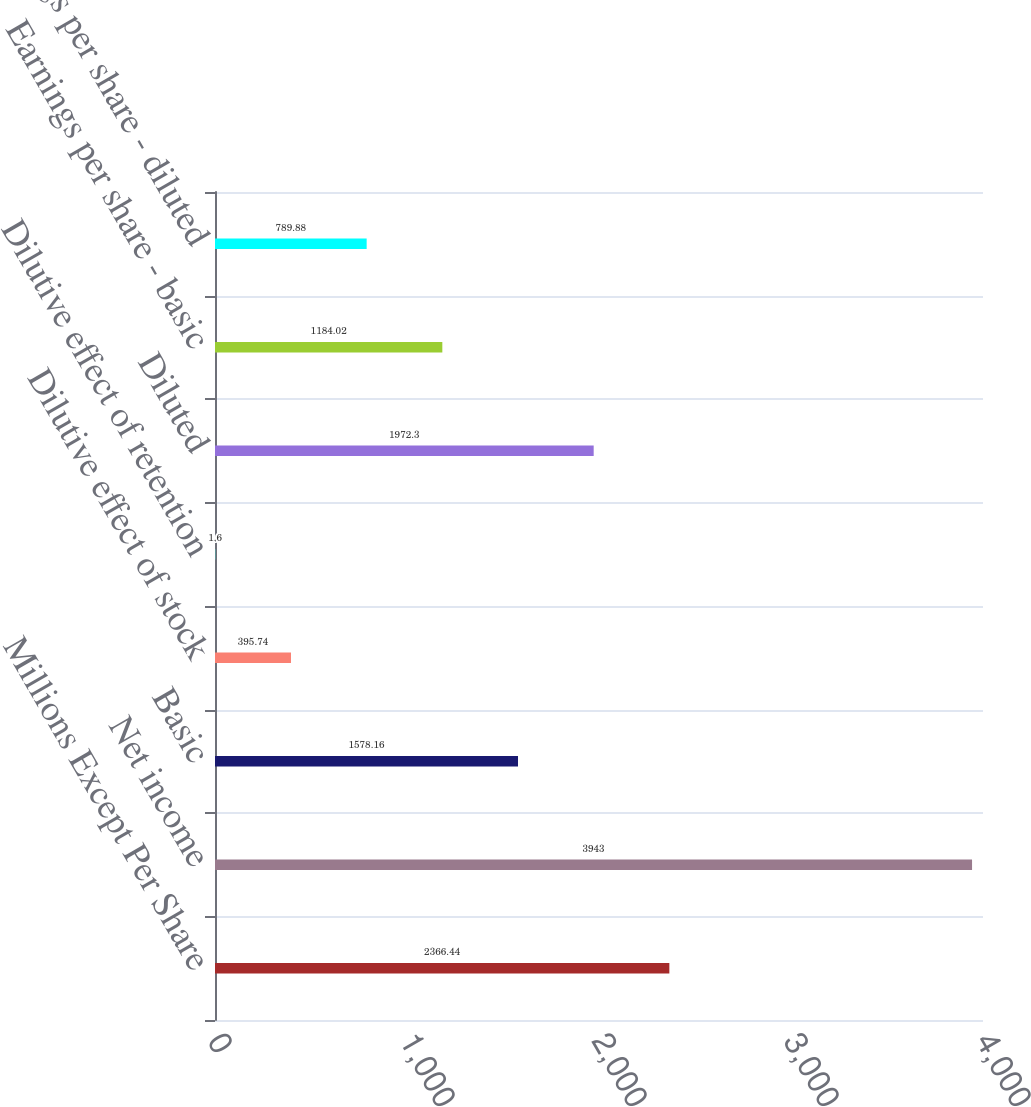Convert chart to OTSL. <chart><loc_0><loc_0><loc_500><loc_500><bar_chart><fcel>Millions Except Per Share<fcel>Net income<fcel>Basic<fcel>Dilutive effect of stock<fcel>Dilutive effect of retention<fcel>Diluted<fcel>Earnings per share - basic<fcel>Earnings per share - diluted<nl><fcel>2366.44<fcel>3943<fcel>1578.16<fcel>395.74<fcel>1.6<fcel>1972.3<fcel>1184.02<fcel>789.88<nl></chart> 